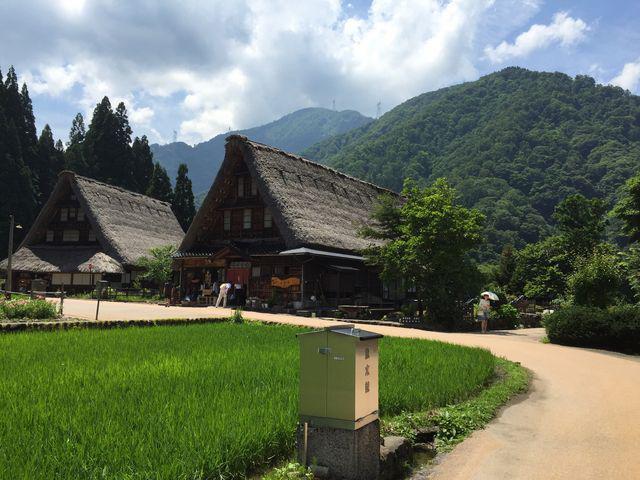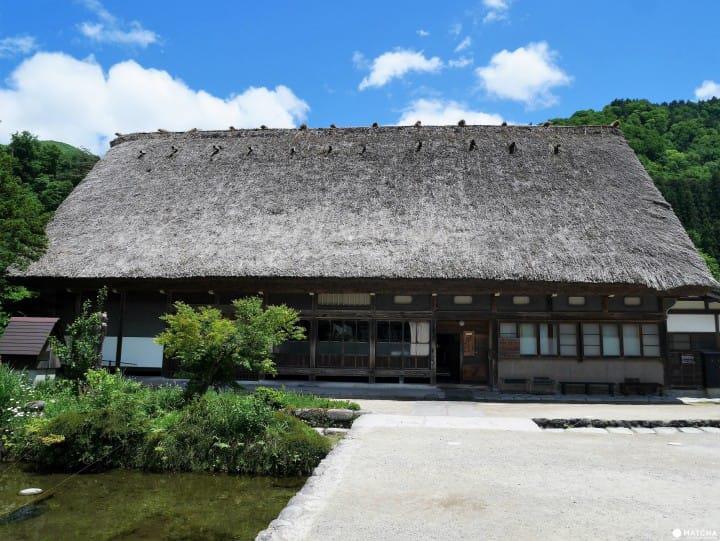The first image is the image on the left, the second image is the image on the right. Considering the images on both sides, is "At least one image shows the front of a white house with scallop trim along the top of the peaked roof, at least one notch in the roof line, and a separate roof over the front door." valid? Answer yes or no. No. The first image is the image on the left, the second image is the image on the right. Considering the images on both sides, is "All the houses have chimneys." valid? Answer yes or no. No. 